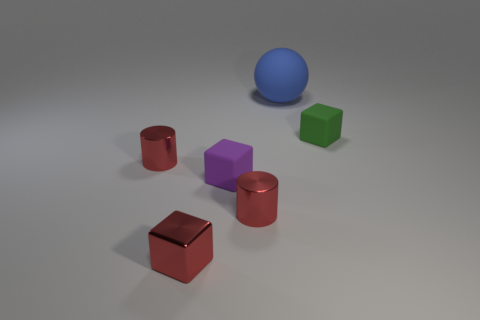Add 3 blue cylinders. How many objects exist? 9 Subtract all balls. How many objects are left? 5 Subtract all brown metallic objects. Subtract all red things. How many objects are left? 3 Add 3 tiny matte objects. How many tiny matte objects are left? 5 Add 3 tiny rubber objects. How many tiny rubber objects exist? 5 Subtract 0 purple cylinders. How many objects are left? 6 